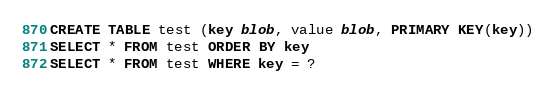<code> <loc_0><loc_0><loc_500><loc_500><_SQL_>CREATE TABLE test (key blob, value blob, PRIMARY KEY(key))
SELECT * FROM test ORDER BY key
SELECT * FROM test WHERE key = ?
</code> 